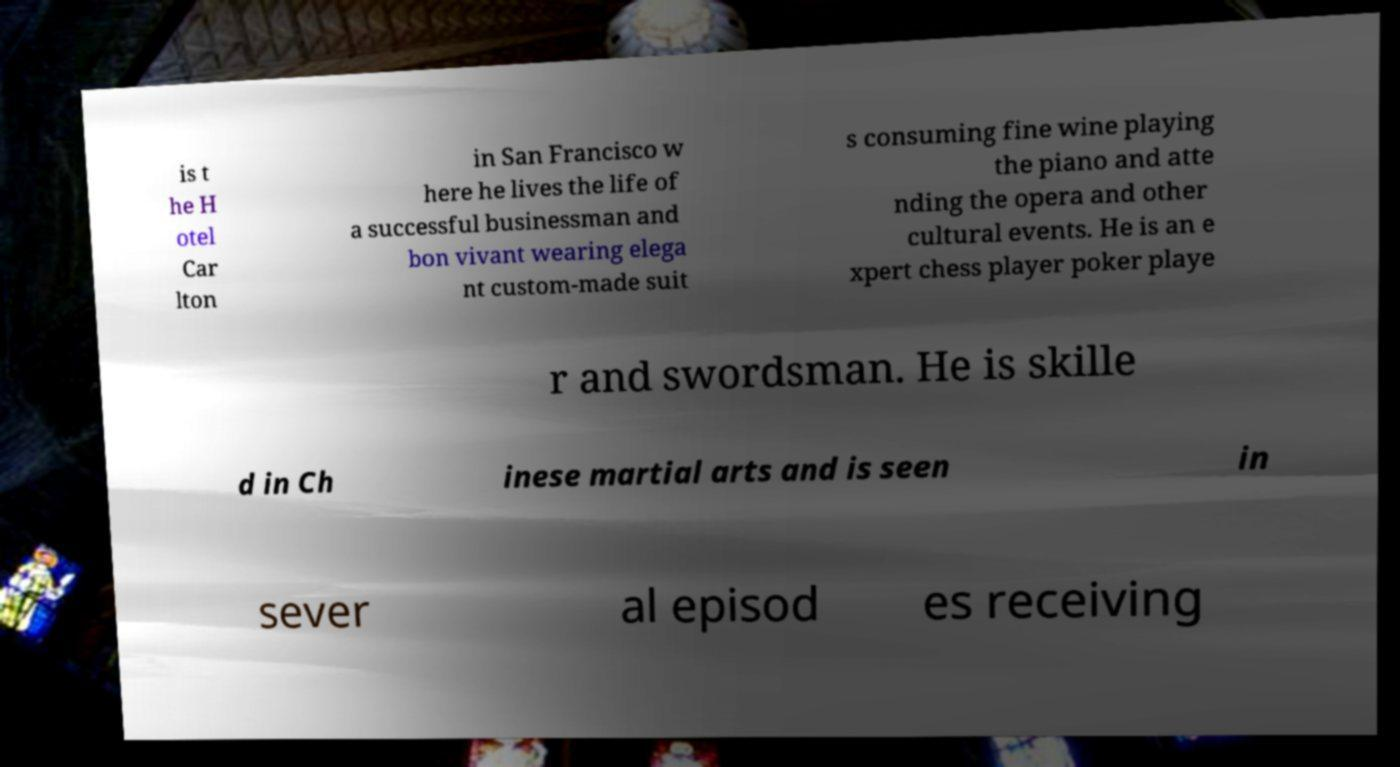What messages or text are displayed in this image? I need them in a readable, typed format. is t he H otel Car lton in San Francisco w here he lives the life of a successful businessman and bon vivant wearing elega nt custom-made suit s consuming fine wine playing the piano and atte nding the opera and other cultural events. He is an e xpert chess player poker playe r and swordsman. He is skille d in Ch inese martial arts and is seen in sever al episod es receiving 